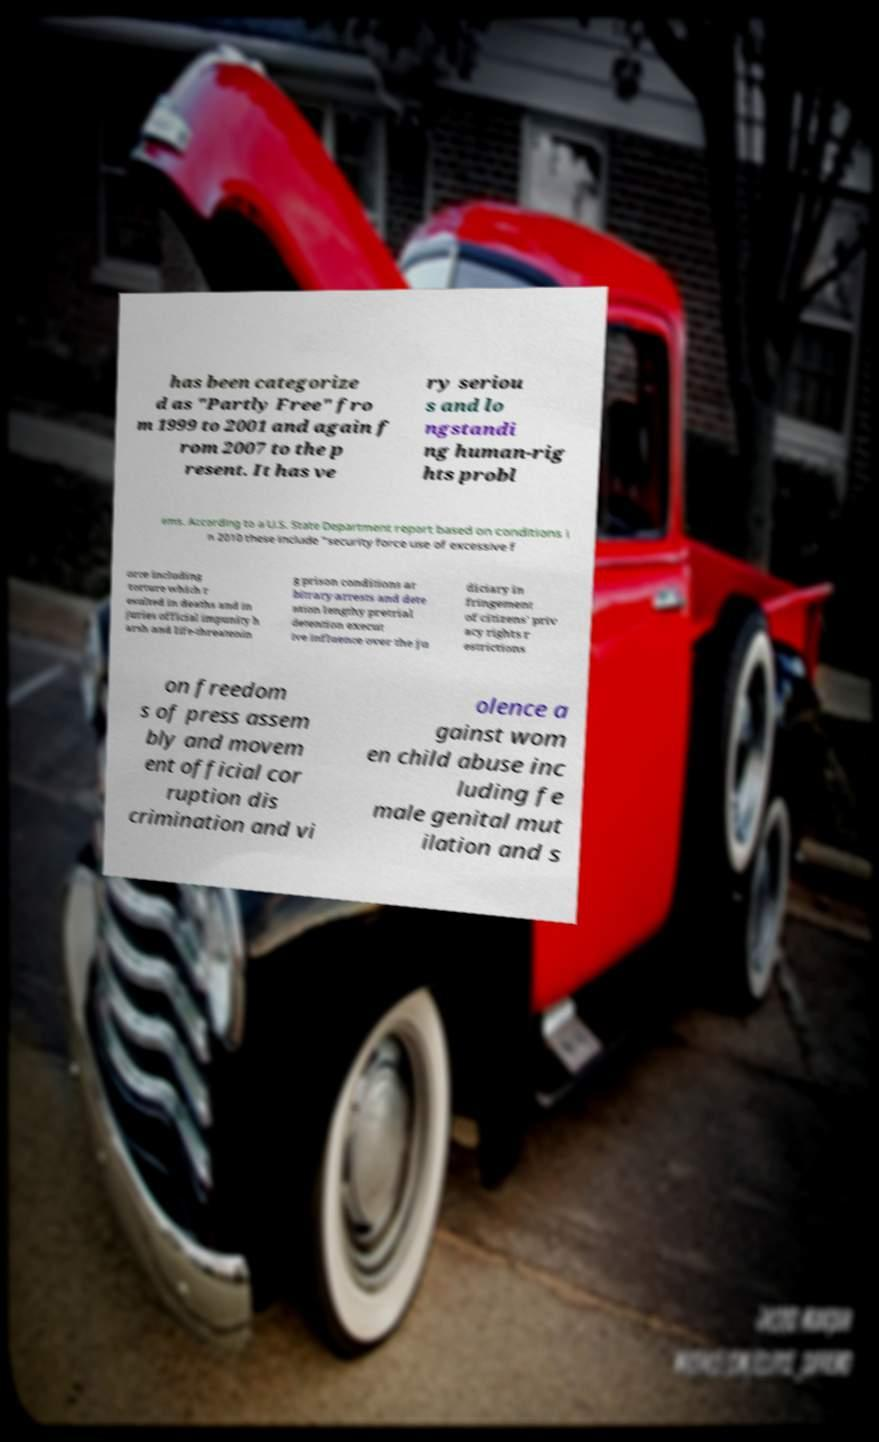Can you accurately transcribe the text from the provided image for me? has been categorize d as "Partly Free" fro m 1999 to 2001 and again f rom 2007 to the p resent. It has ve ry seriou s and lo ngstandi ng human-rig hts probl ems. According to a U.S. State Department report based on conditions i n 2010 these include "security force use of excessive f orce including torture which r esulted in deaths and in juries official impunity h arsh and life-threatenin g prison conditions ar bitrary arrests and dete ntion lengthy pretrial detention execut ive influence over the ju diciary in fringement of citizens' priv acy rights r estrictions on freedom s of press assem bly and movem ent official cor ruption dis crimination and vi olence a gainst wom en child abuse inc luding fe male genital mut ilation and s 